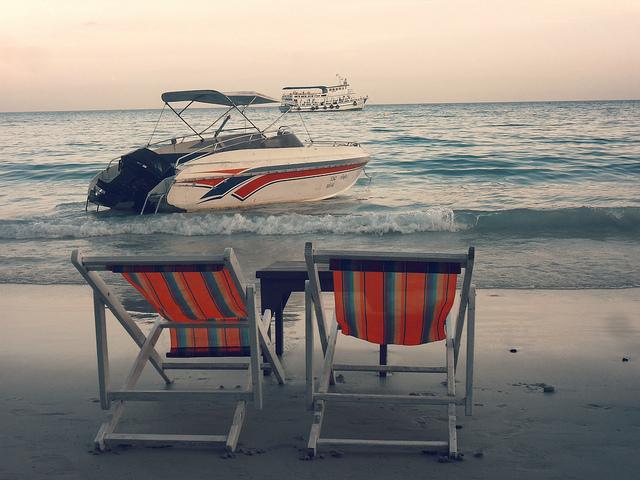What is being used for shade?
Answer briefly. Nothing. Is this daytime?
Concise answer only. Yes. Are there people nearby that we can't see?
Be succinct. Yes. Are they shipwrecked?
Quick response, please. No. 